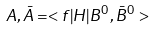Convert formula to latex. <formula><loc_0><loc_0><loc_500><loc_500>A , \bar { A } = < f | H | B ^ { 0 } , \bar { B } ^ { 0 } ></formula> 